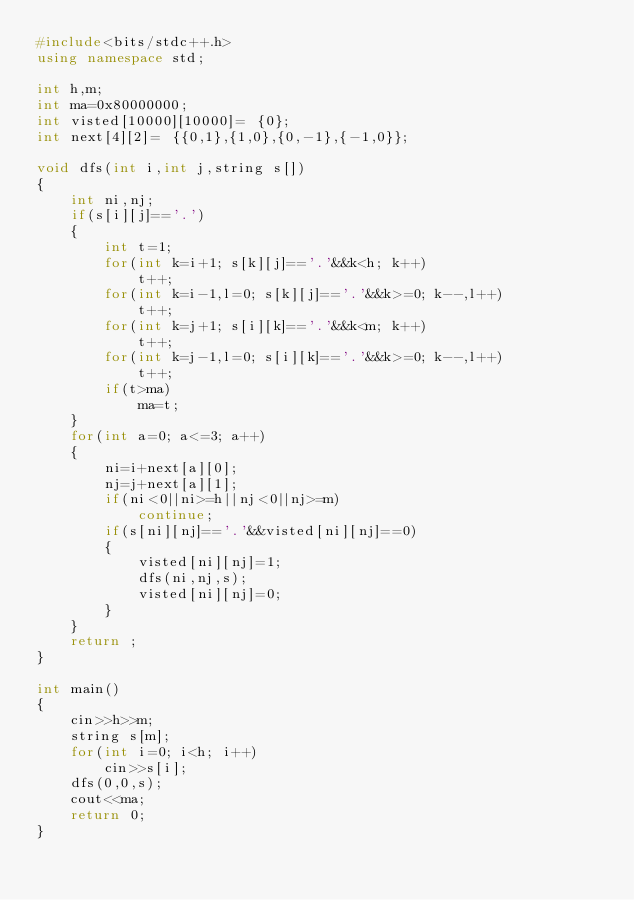<code> <loc_0><loc_0><loc_500><loc_500><_C++_>#include<bits/stdc++.h>
using namespace std;

int h,m;
int ma=0x80000000;
int visted[10000][10000]= {0};
int next[4][2]= {{0,1},{1,0},{0,-1},{-1,0}};

void dfs(int i,int j,string s[])
{
    int ni,nj;
    if(s[i][j]=='.')
    {
        int t=1;
        for(int k=i+1; s[k][j]=='.'&&k<h; k++)
            t++;
        for(int k=i-1,l=0; s[k][j]=='.'&&k>=0; k--,l++)
            t++;
        for(int k=j+1; s[i][k]=='.'&&k<m; k++)
            t++;
        for(int k=j-1,l=0; s[i][k]=='.'&&k>=0; k--,l++)
            t++;
        if(t>ma)
            ma=t;
    }
    for(int a=0; a<=3; a++)
    {
        ni=i+next[a][0];
        nj=j+next[a][1];
        if(ni<0||ni>=h||nj<0||nj>=m)
            continue;
        if(s[ni][nj]=='.'&&visted[ni][nj]==0)
        {
            visted[ni][nj]=1;
            dfs(ni,nj,s);
            visted[ni][nj]=0;
        }
    }
    return ;
}

int main()
{
    cin>>h>>m;
    string s[m];
    for(int i=0; i<h; i++)
        cin>>s[i];
    dfs(0,0,s);
    cout<<ma;
    return 0;
}
</code> 